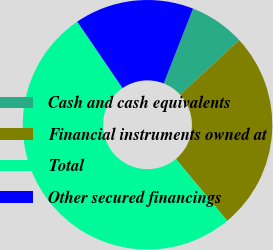Convert chart. <chart><loc_0><loc_0><loc_500><loc_500><pie_chart><fcel>Cash and cash equivalents<fcel>Financial instruments owned at<fcel>Total<fcel>Other secured financings<nl><fcel>7.2%<fcel>25.83%<fcel>51.51%<fcel>15.46%<nl></chart> 